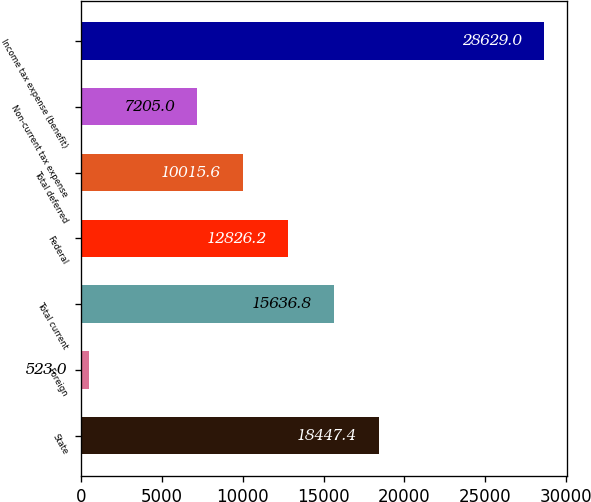Convert chart to OTSL. <chart><loc_0><loc_0><loc_500><loc_500><bar_chart><fcel>State<fcel>Foreign<fcel>Total current<fcel>Federal<fcel>Total deferred<fcel>Non-current tax expense<fcel>Income tax expense (benefit)<nl><fcel>18447.4<fcel>523<fcel>15636.8<fcel>12826.2<fcel>10015.6<fcel>7205<fcel>28629<nl></chart> 